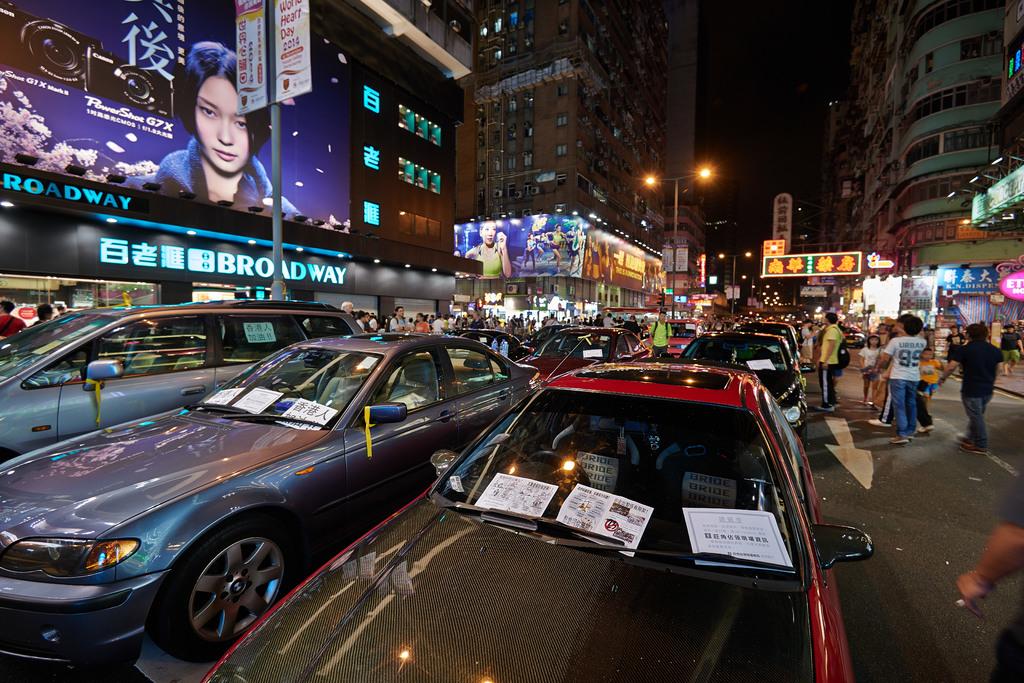What is written on the blue marquee about the minivan?
Offer a very short reply. Broadway. What is written below the picture of the lady?
Make the answer very short. Broadway. 